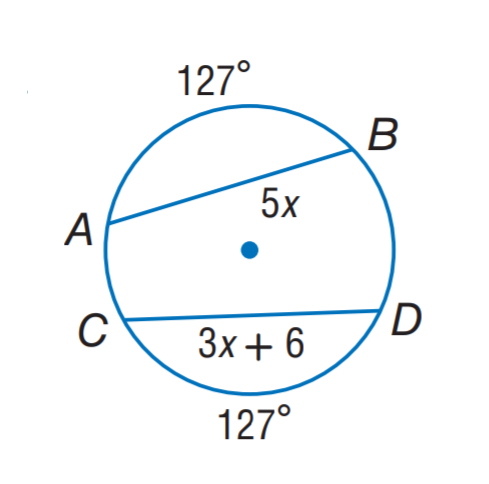Answer the mathemtical geometry problem and directly provide the correct option letter.
Question: Find x.
Choices: A: 3 B: 4 C: 5 D: 6 A 